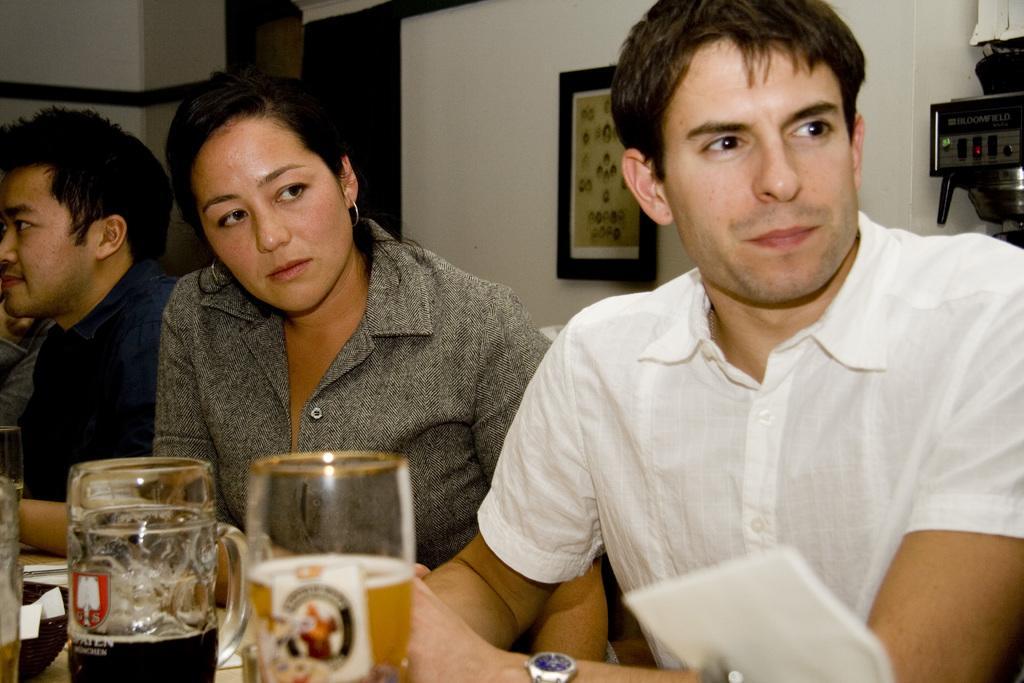Can you describe this image briefly? In this image, we can see few people. At the bottom, we can see glasses with liquids, some objects. Background there is a wall, photo frame, some machine. 